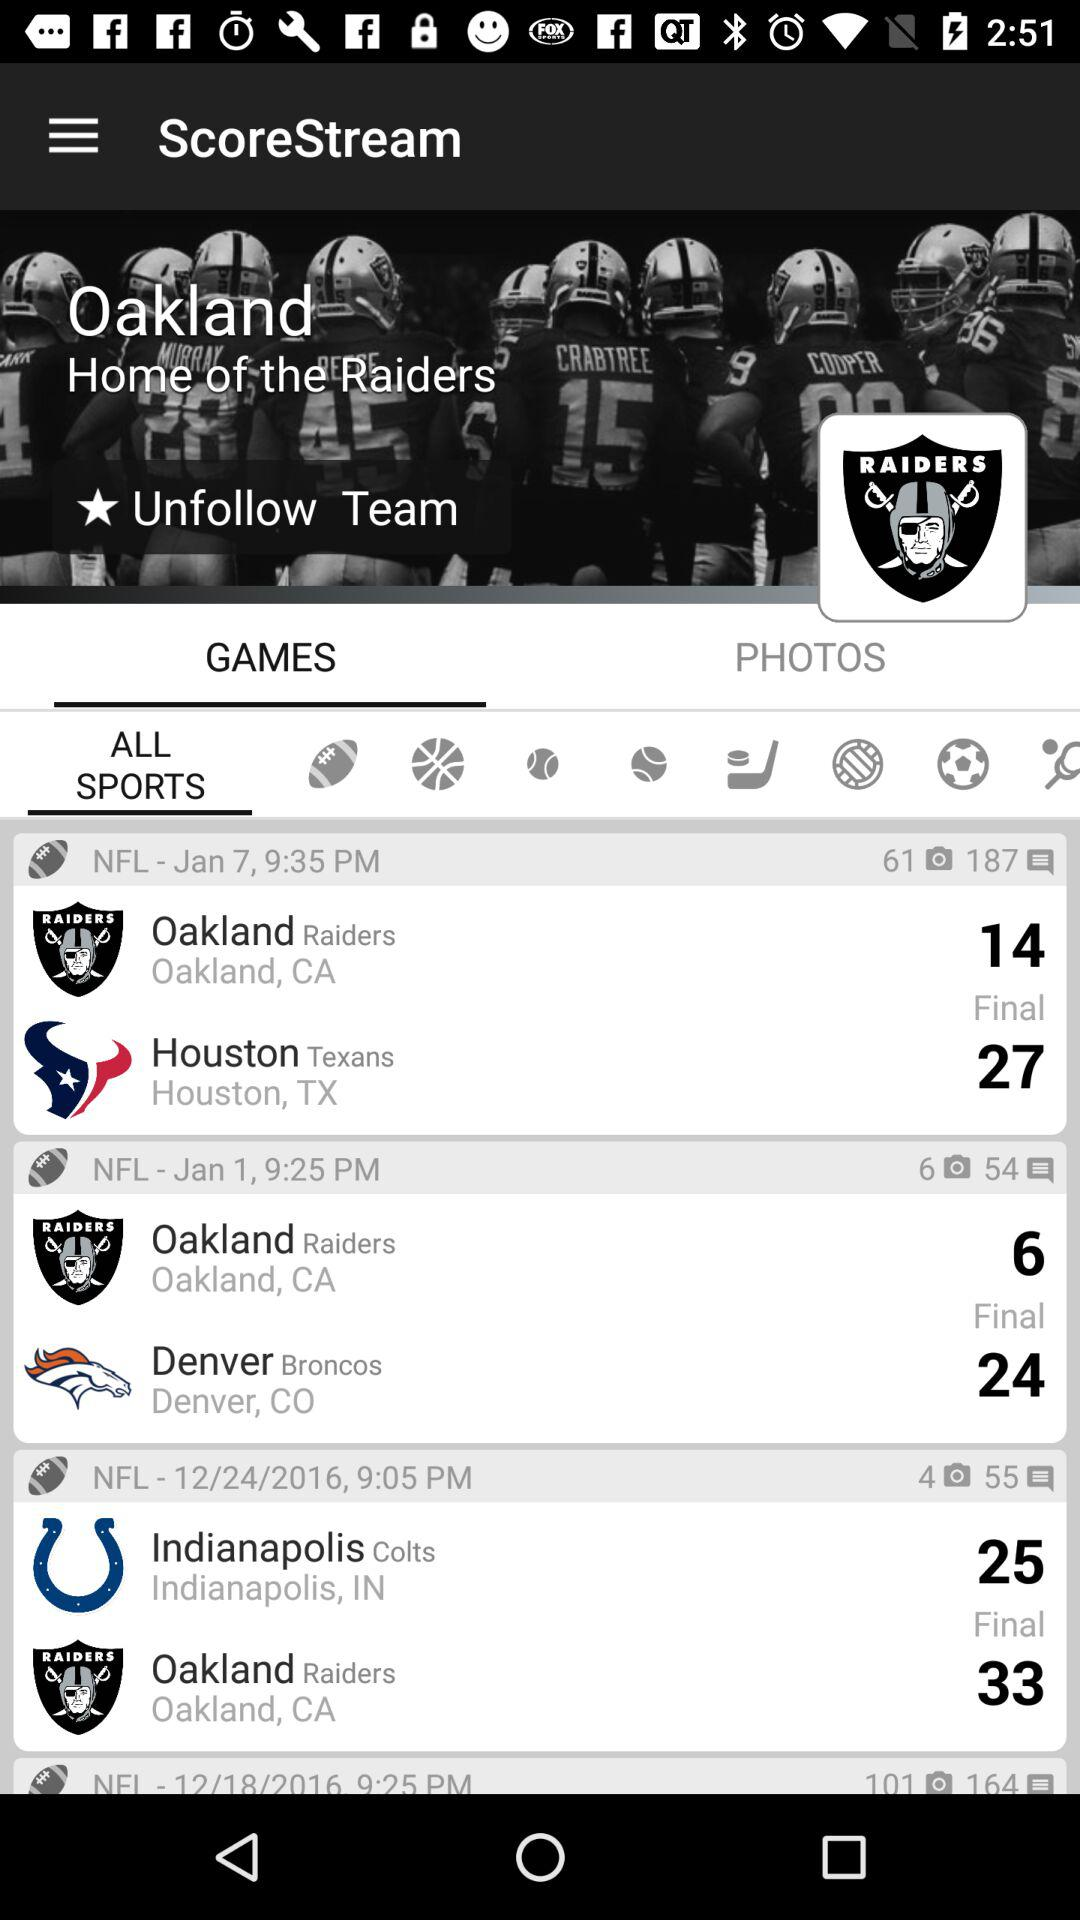How many more games do the Raiders have than the Texans?
Answer the question using a single word or phrase. 1 